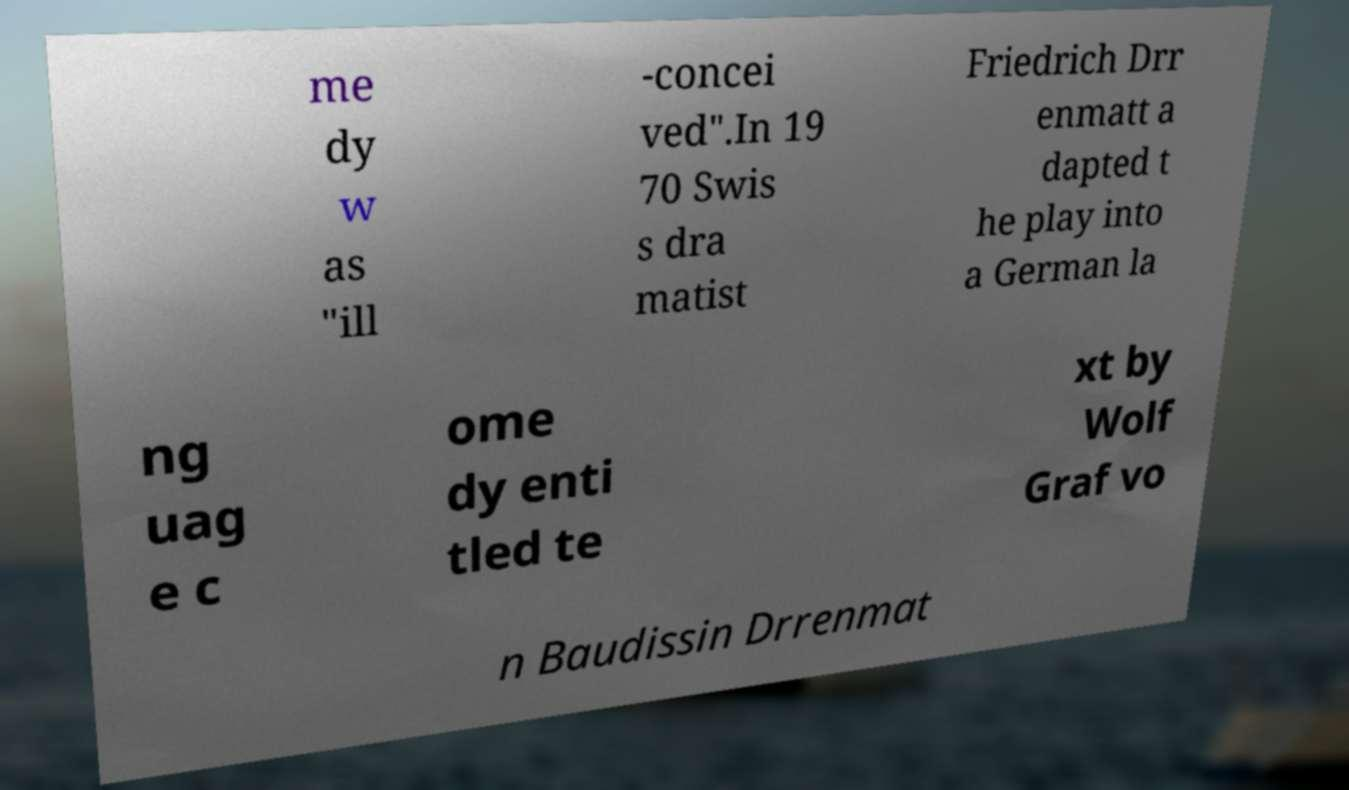I need the written content from this picture converted into text. Can you do that? me dy w as "ill -concei ved".In 19 70 Swis s dra matist Friedrich Drr enmatt a dapted t he play into a German la ng uag e c ome dy enti tled te xt by Wolf Graf vo n Baudissin Drrenmat 